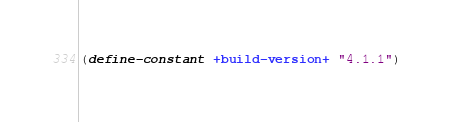Convert code to text. <code><loc_0><loc_0><loc_500><loc_500><_Scheme_>(define-constant +build-version+ "4.1.1")
</code> 